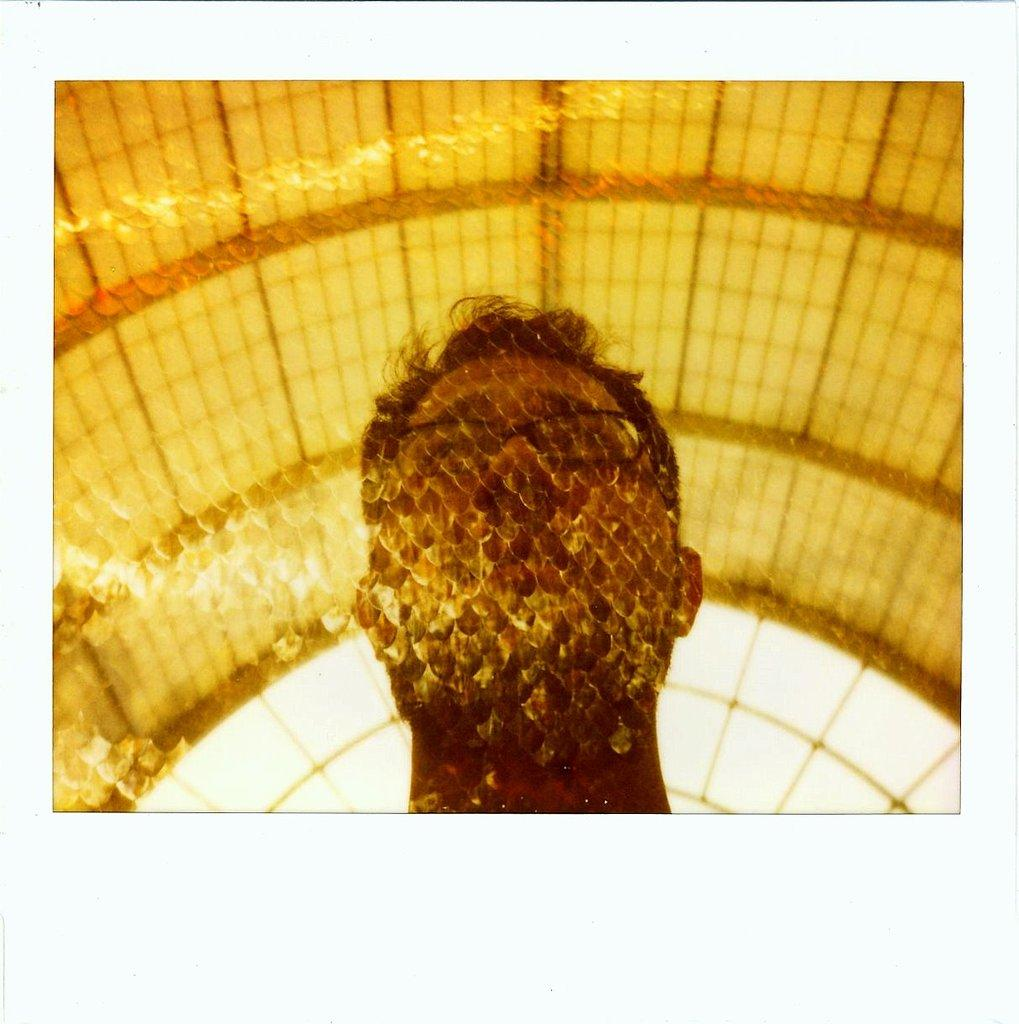What is the main subject in the middle of the image? There is a person's head in the middle of the image. What color is the roof in the image? The roof in the image is yellow. How many fingers can be seen in the image? There is no information about fingers in the image, as it only shows a person's head and a yellow roof. 